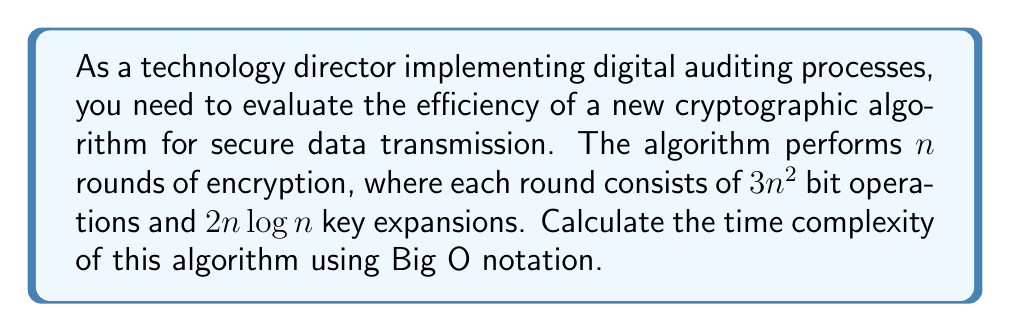Provide a solution to this math problem. Let's break down the problem and solve it step-by-step:

1. Identify the components:
   - Number of rounds: $n$
   - Bit operations per round: $3n^2$
   - Key expansions per round: $2n \log n$

2. Calculate the total number of operations:
   - Bit operations: $n \cdot 3n^2 = 3n^3$
   - Key expansions: $n \cdot 2n \log n = 2n^2 \log n$

3. Combine the operations:
   Total operations = $3n^3 + 2n^2 \log n$

4. Identify the dominant term:
   As $n$ grows, $3n^3$ grows faster than $2n^2 \log n$

5. Apply Big O notation:
   The time complexity is $O(n^3)$, as we only consider the highest order term and drop constants.

This means that as the input size $n$ increases, the running time of the algorithm grows cubically.
Answer: $O(n^3)$ 